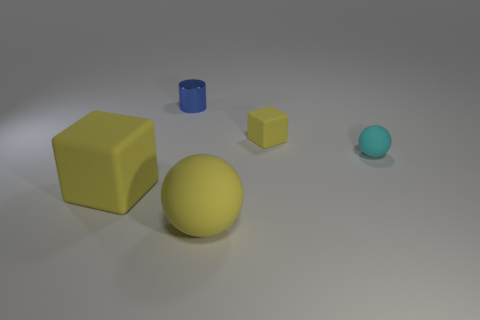Is the number of small objects that are to the right of the big yellow rubber sphere greater than the number of yellow blocks? no 